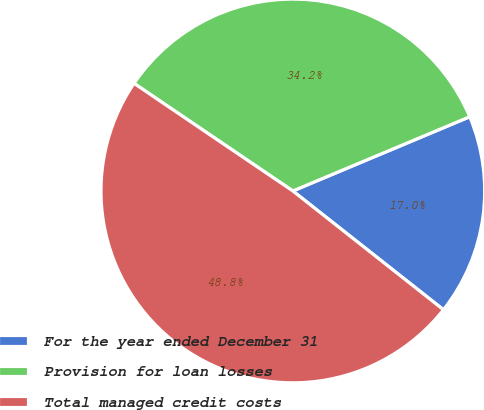<chart> <loc_0><loc_0><loc_500><loc_500><pie_chart><fcel>For the year ended December 31<fcel>Provision for loan losses<fcel>Total managed credit costs<nl><fcel>16.95%<fcel>34.2%<fcel>48.85%<nl></chart> 